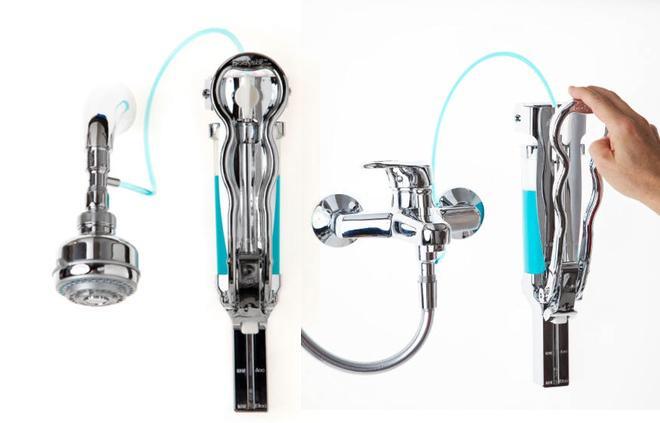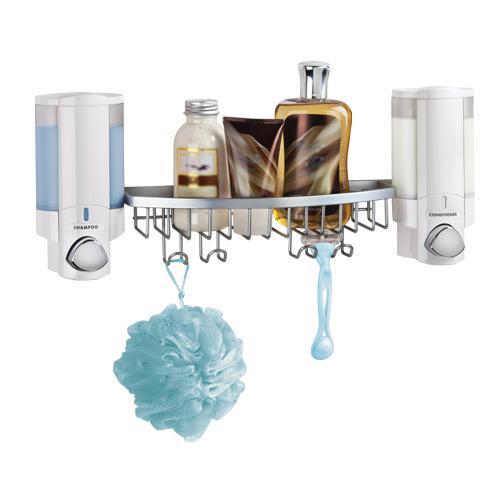The first image is the image on the left, the second image is the image on the right. Considering the images on both sides, is "Each image contains at least three dispensers in a line." valid? Answer yes or no. No. The first image is the image on the left, the second image is the image on the right. Analyze the images presented: Is the assertion "At least one image shows a chrome rack with a suspended round scrubber, between two dispensers." valid? Answer yes or no. Yes. 